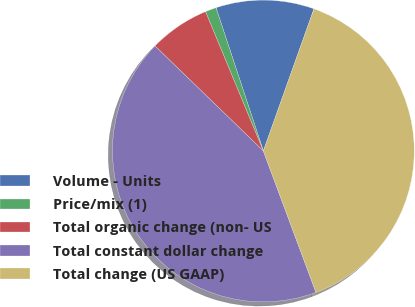<chart> <loc_0><loc_0><loc_500><loc_500><pie_chart><fcel>Volume - Units<fcel>Price/mix (1)<fcel>Total organic change (non- US<fcel>Total constant dollar change<fcel>Total change (US GAAP)<nl><fcel>10.53%<fcel>1.18%<fcel>6.49%<fcel>42.92%<fcel>38.89%<nl></chart> 